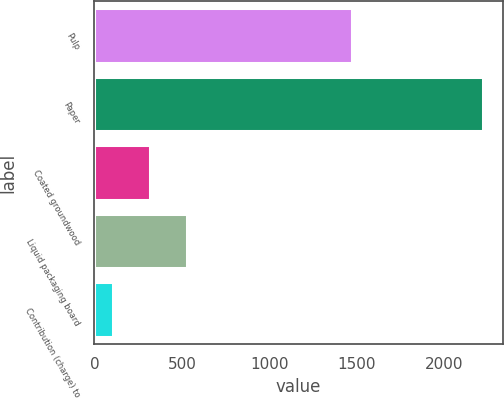<chart> <loc_0><loc_0><loc_500><loc_500><bar_chart><fcel>Pulp<fcel>Paper<fcel>Coated groundwood<fcel>Liquid packaging board<fcel>Contribution (charge) to<nl><fcel>1471<fcel>2226<fcel>316.2<fcel>528.4<fcel>104<nl></chart> 